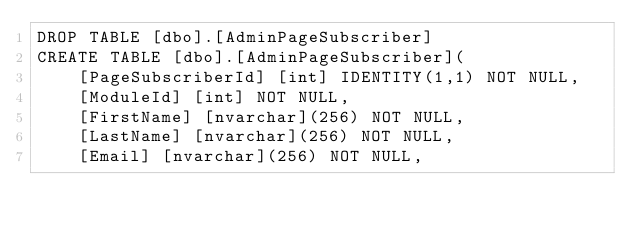<code> <loc_0><loc_0><loc_500><loc_500><_SQL_>DROP TABLE [dbo].[AdminPageSubscriber]
CREATE TABLE [dbo].[AdminPageSubscriber](
	[PageSubscriberId] [int] IDENTITY(1,1) NOT NULL,
	[ModuleId] [int] NOT NULL,
	[FirstName] [nvarchar](256) NOT NULL,
	[LastName] [nvarchar](256) NOT NULL,
	[Email] [nvarchar](256) NOT NULL,</code> 